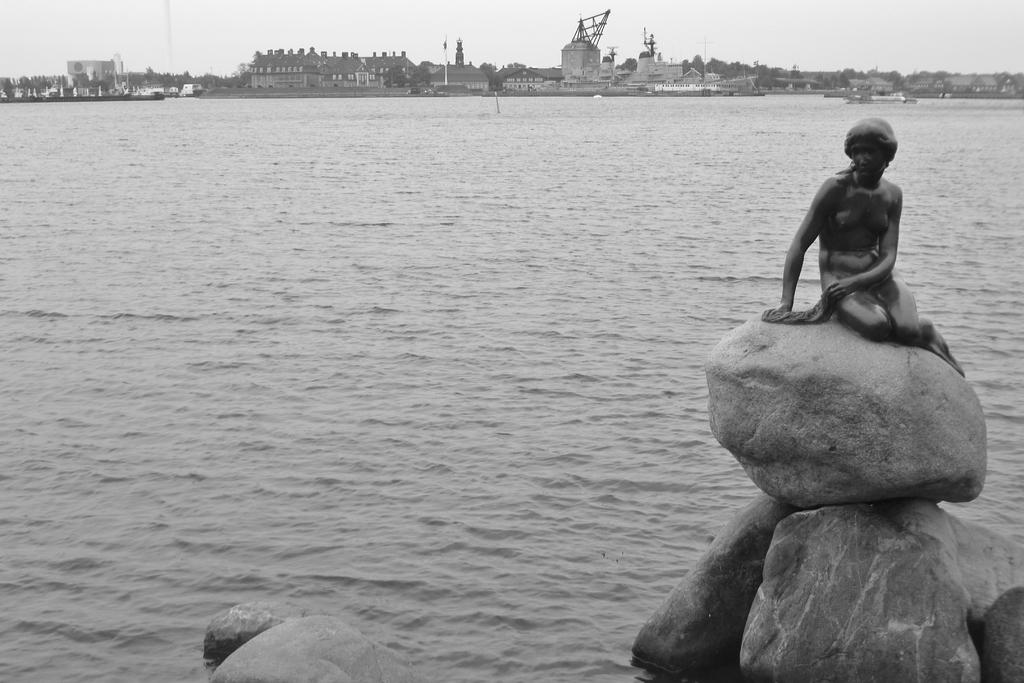What is the main subject of the image? There is a human statue in the image. Where is the human statue located? The human statue is sitting on rocks. What can be seen in the background of the image? There are buildings in the background of the image. What is the condition of the sky in the image? The sky is clear in the image. What is the color scheme of the image? The image is in black and white color. Can you tell me how many jokes are being told by the hydrant in the image? There is no hydrant present in the image, and therefore no jokes can be told by it. Is there an island visible in the image? There is no island visible in the image; it features a human statue sitting on rocks near a lake with buildings in the background. 